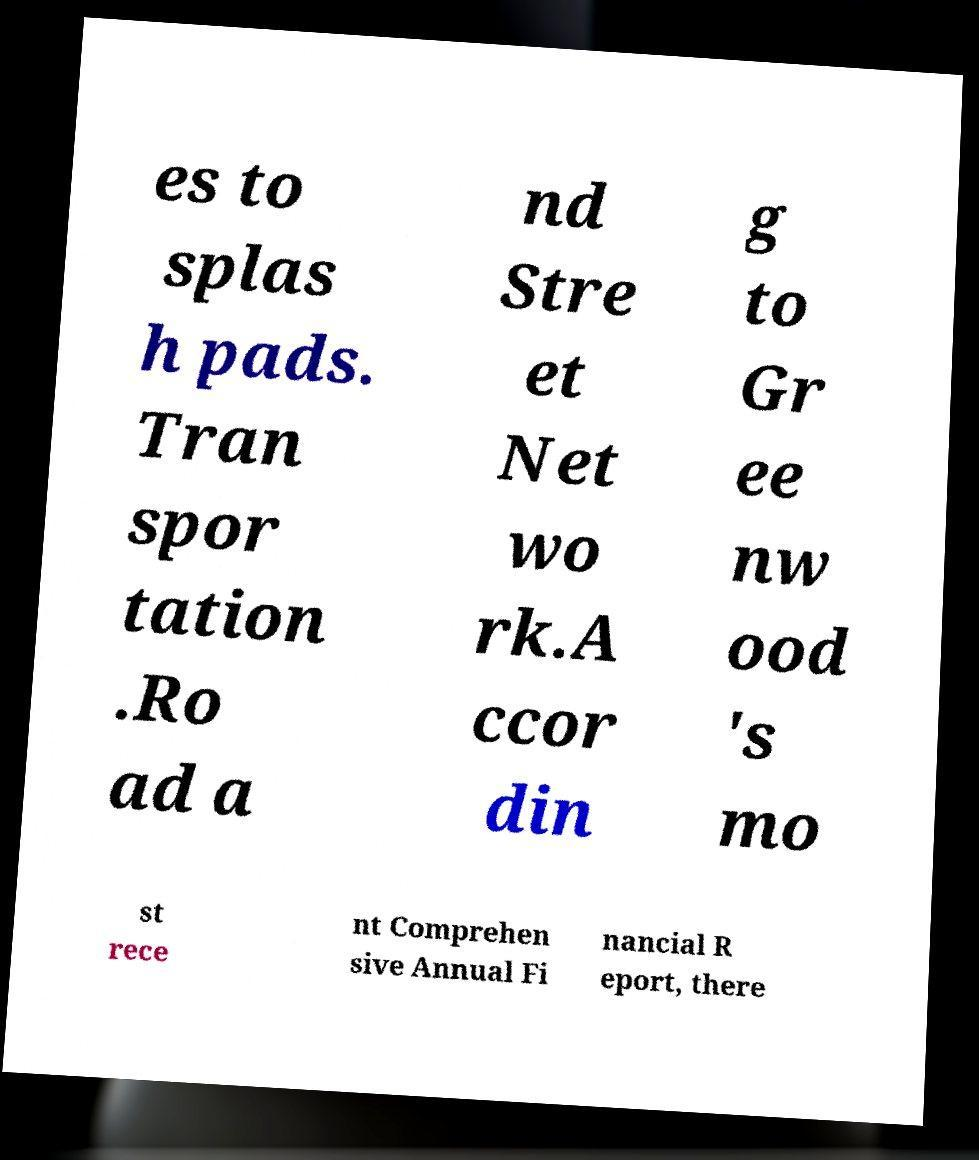Can you read and provide the text displayed in the image?This photo seems to have some interesting text. Can you extract and type it out for me? es to splas h pads. Tran spor tation .Ro ad a nd Stre et Net wo rk.A ccor din g to Gr ee nw ood 's mo st rece nt Comprehen sive Annual Fi nancial R eport, there 